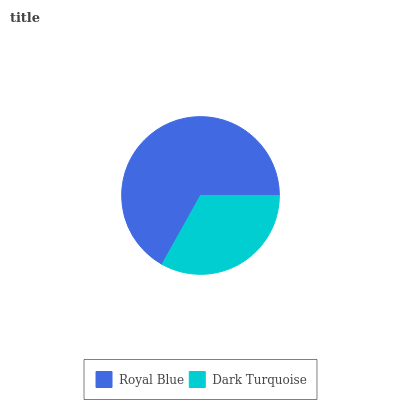Is Dark Turquoise the minimum?
Answer yes or no. Yes. Is Royal Blue the maximum?
Answer yes or no. Yes. Is Dark Turquoise the maximum?
Answer yes or no. No. Is Royal Blue greater than Dark Turquoise?
Answer yes or no. Yes. Is Dark Turquoise less than Royal Blue?
Answer yes or no. Yes. Is Dark Turquoise greater than Royal Blue?
Answer yes or no. No. Is Royal Blue less than Dark Turquoise?
Answer yes or no. No. Is Royal Blue the high median?
Answer yes or no. Yes. Is Dark Turquoise the low median?
Answer yes or no. Yes. Is Dark Turquoise the high median?
Answer yes or no. No. Is Royal Blue the low median?
Answer yes or no. No. 